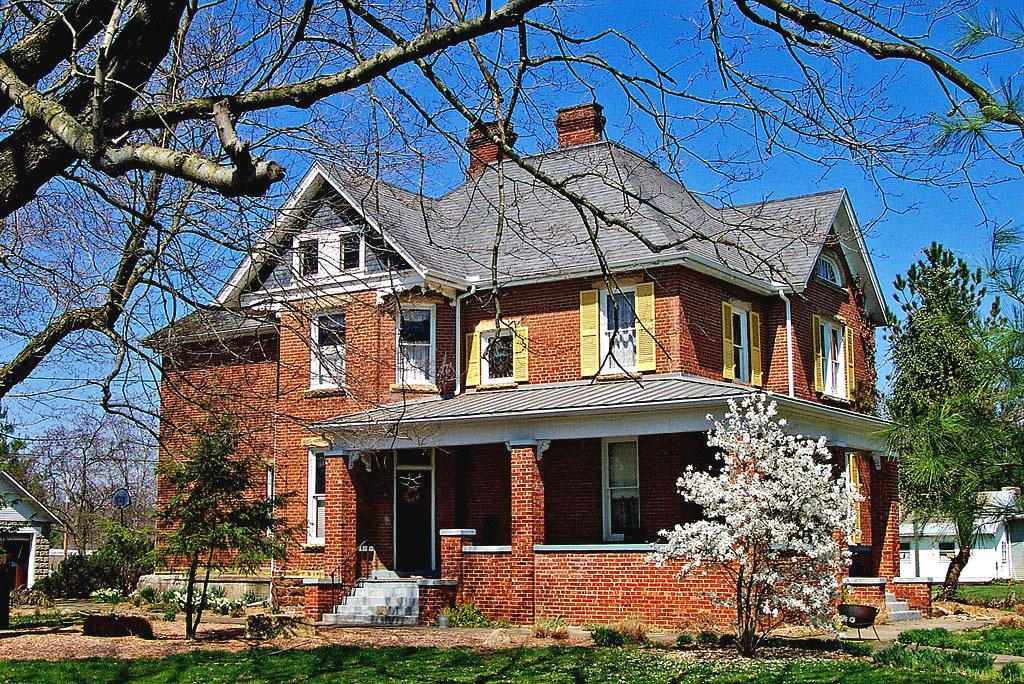What type of structure is visible in the image? There is a house in the image. What features can be seen on the house? The house has a roof, windows, and stairs. What type of vegetation is present in the image? There are plants, grass, and trees in the image. Can you describe the branches of the trees in the image? Yes, there are branches of the trees visible in the image. What is visible in the sky in the image? The sky is visible in the image, and it looks cloudy. What is the son of the stranger doing in the image? There is no son or stranger present in the image; it only features a house, plants, grass, trees, and a cloudy sky. 